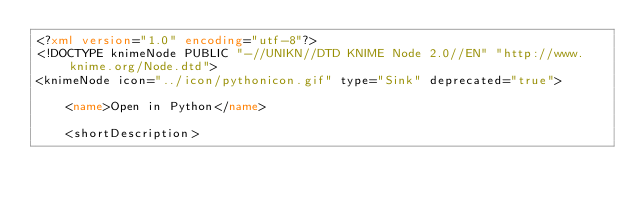<code> <loc_0><loc_0><loc_500><loc_500><_XML_><?xml version="1.0" encoding="utf-8"?>
<!DOCTYPE knimeNode PUBLIC "-//UNIKN//DTD KNIME Node 2.0//EN" "http://www.knime.org/Node.dtd">
<knimeNode icon="../icon/pythonicon.gif" type="Sink" deprecated="true">

    <name>Open in Python</name>

    <shortDescription></code> 